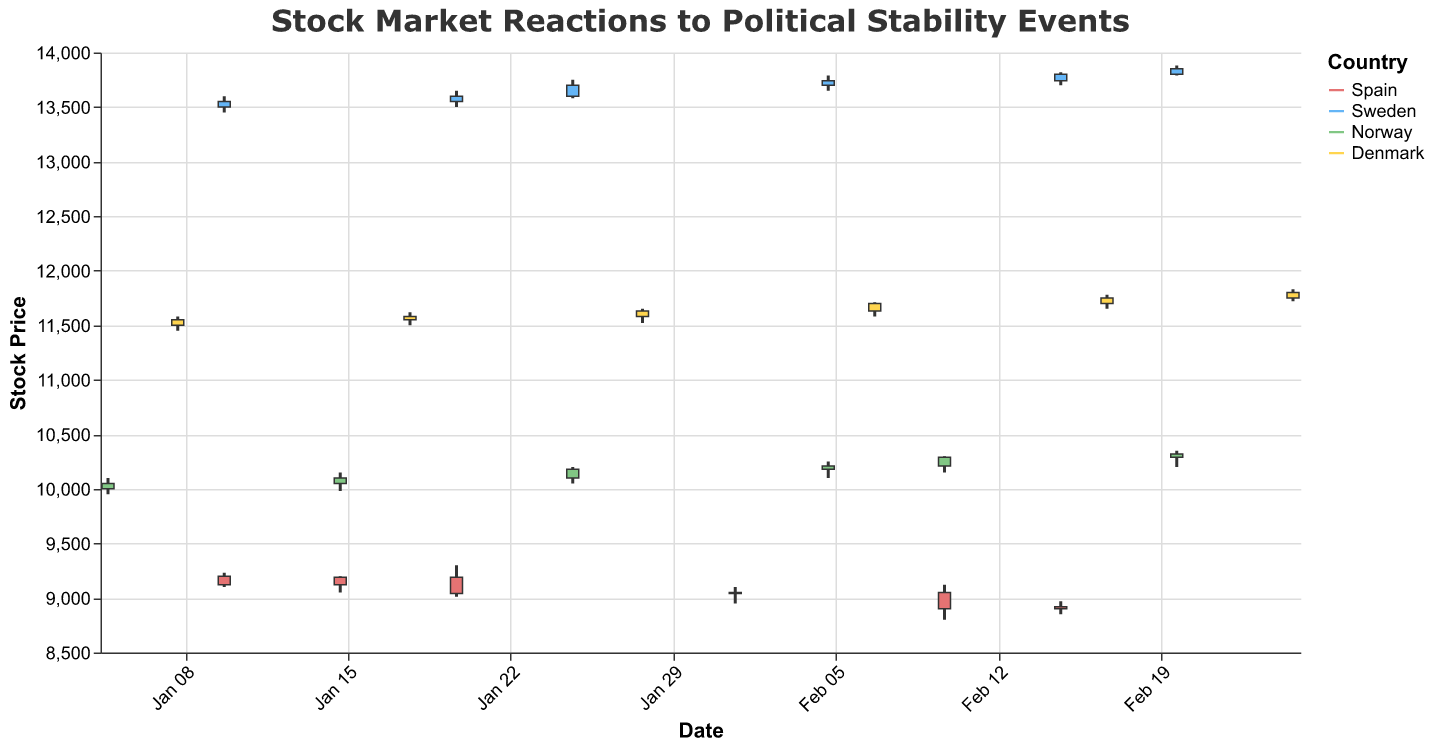What is the title of the figure? The title is displayed at the top of the figure in a larger font size. The text specifies the overall theme being presented.
Answer: Stock Market Reactions to Political Stability Events Which country has the highest closing stock price over the observed period? By comparing the closing stock prices from all countries, Denmark has the highest closing price on February 25th, 2023 with a value of 11800.
Answer: Denmark On which date did Spain experience public protests, and what was the volume of trades on that day? Locate the event "Public Protests" in the Candlestick plot for Spain and note the given volume information. Spain experienced public protests on February 10th, 2023, with a trade volume of 875000.
Answer: February 10, 875000 How does the stock price reaction to an Economic Growth Report in Sweden compare to an Economic Stability Report in Norway? By observing the events for both countries, Sweden had an Economic Growth Report on February 15th with a closing price of 13800. Norway had an Economic Stability Report on February 20th with a closing price of 10320. Thus, Sweden's closing price was higher on their respective days.
Answer: Sweden's closing price is higher Which event in Spain shows the largest range (difference between high and low prices) in stock prices? Determine the difference between the high and low prices for each event in Spain:
- Political Scandal: 9230 - 9100 = 130
- Government Policy Change: 9200 - 9050 = 150
- Prime Minister Resignation: 9300 - 9010 = 290
- New Election Announcement: 9100 - 8950 = 150
- Public Protests: 9120 - 8800 = 320
- Policy Reform: 8970 - 8850 = 120
So the Public Protests event on February 10th shows the largest range of 320.
Answer: Public Protests, 320 What was the stock price trend in Norway from the Peace Treaty Signing to the Economic Stability Report? Evaluate the closing prices for these events:
- Peace Treaty Signing: 10050
- Prime Minister Speech: 10100
- Environmental Policy Passed: 10180
- International Agreement: 10210
- Government Stability Report: 10290
- Economic Stability Report: 10320
From January 5th to February 20th, the stock price in Norway exhibits an upward trend.
Answer: Upward trend During which event in Spain did the stock market exhibit the steepest decline in closing price compared to the previous event? By examining the closing prices and their changes for consecutive events:
- Political Scandal to Government Policy Change: 9190 - 9120 = 70 increase
- Government Policy Change to Prime Minister Resignation: 9040 - 9190 = 150 decrease
- Prime Minister Resignation to New Election Announcement: 9050 - 9040 = 10 increase
- New Election Announcement to Public Protests: 8900 - 9050 = 150 decrease
- Public Protests to Policy Reform: 8920 - 8900 = 20 increase
The steepest decline is observed during the Prime Minister Resignation event with a decrease of 150.
Answer: Prime Minister Resignation Which Scandinavian country showed the most consistent upward trend in stock prices during the observed period? Review the closing prices of each Scandinavian country:
- Sweden exhibits a consistent rise from 13550 to 13850.
- Norway has steady increases from 10050 up to 10320, but with smaller price steps.
- Denmark shows gradual increases from 11550 to 11800, but with noticeable stability between some points.
Sweden displays the clearest, most consistent upward trend.
Answer: Sweden 